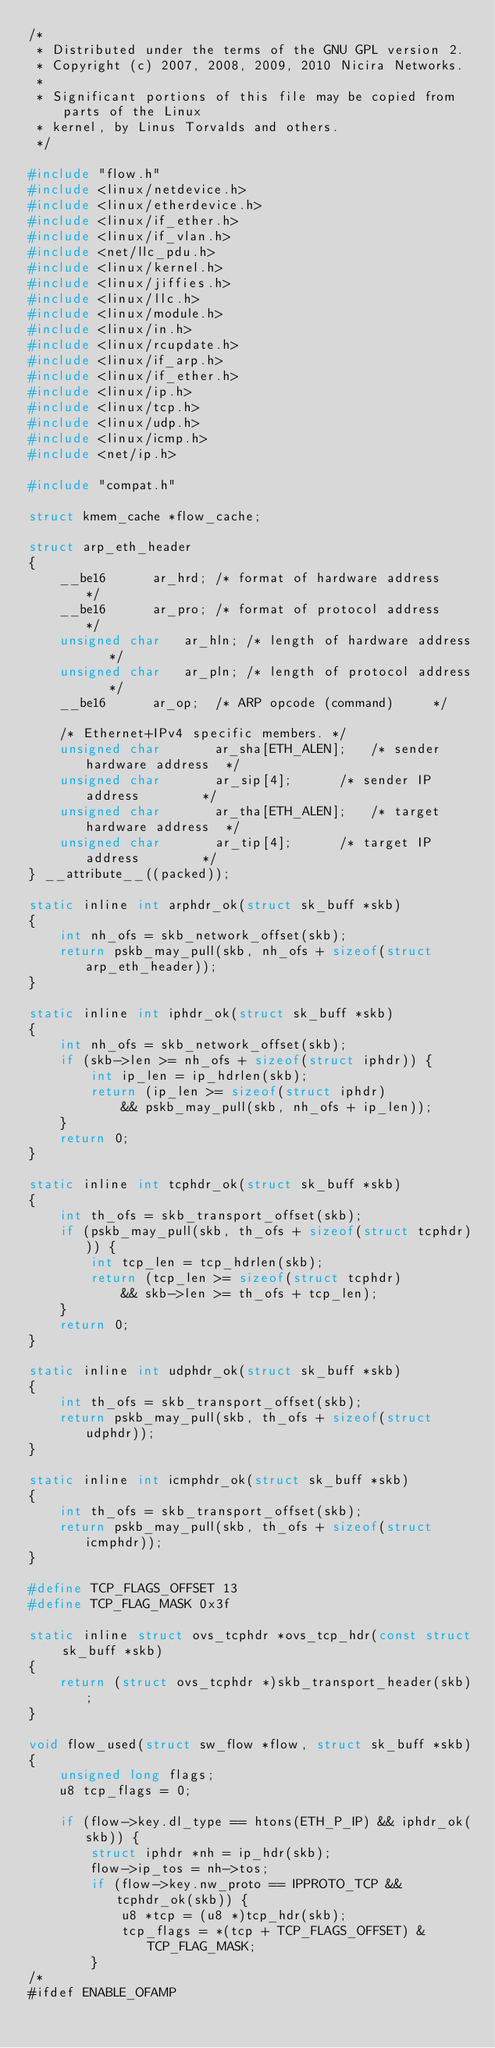Convert code to text. <code><loc_0><loc_0><loc_500><loc_500><_C_>/*
 * Distributed under the terms of the GNU GPL version 2.
 * Copyright (c) 2007, 2008, 2009, 2010 Nicira Networks.
 *
 * Significant portions of this file may be copied from parts of the Linux
 * kernel, by Linus Torvalds and others.
 */

#include "flow.h"
#include <linux/netdevice.h>
#include <linux/etherdevice.h>
#include <linux/if_ether.h>
#include <linux/if_vlan.h>
#include <net/llc_pdu.h>
#include <linux/kernel.h>
#include <linux/jiffies.h>
#include <linux/llc.h>
#include <linux/module.h>
#include <linux/in.h>
#include <linux/rcupdate.h>
#include <linux/if_arp.h>
#include <linux/if_ether.h>
#include <linux/ip.h>
#include <linux/tcp.h>
#include <linux/udp.h>
#include <linux/icmp.h>
#include <net/ip.h>

#include "compat.h"

struct kmem_cache *flow_cache;

struct arp_eth_header
{
	__be16      ar_hrd;	/* format of hardware address   */
	__be16      ar_pro;	/* format of protocol address   */
	unsigned char   ar_hln;	/* length of hardware address   */
	unsigned char   ar_pln;	/* length of protocol address   */
	__be16      ar_op;	/* ARP opcode (command)     */

	/* Ethernet+IPv4 specific members. */
	unsigned char       ar_sha[ETH_ALEN];	/* sender hardware address  */
	unsigned char       ar_sip[4];		/* sender IP address        */
	unsigned char       ar_tha[ETH_ALEN];	/* target hardware address  */
	unsigned char       ar_tip[4];		/* target IP address        */
} __attribute__((packed));

static inline int arphdr_ok(struct sk_buff *skb)
{
	int nh_ofs = skb_network_offset(skb);
	return pskb_may_pull(skb, nh_ofs + sizeof(struct arp_eth_header));
}

static inline int iphdr_ok(struct sk_buff *skb)
{
	int nh_ofs = skb_network_offset(skb);
	if (skb->len >= nh_ofs + sizeof(struct iphdr)) {
		int ip_len = ip_hdrlen(skb);
		return (ip_len >= sizeof(struct iphdr)
			&& pskb_may_pull(skb, nh_ofs + ip_len));
	}
	return 0;
}

static inline int tcphdr_ok(struct sk_buff *skb)
{
	int th_ofs = skb_transport_offset(skb);
	if (pskb_may_pull(skb, th_ofs + sizeof(struct tcphdr))) {
		int tcp_len = tcp_hdrlen(skb);
		return (tcp_len >= sizeof(struct tcphdr)
			&& skb->len >= th_ofs + tcp_len);
	}
	return 0;
}

static inline int udphdr_ok(struct sk_buff *skb)
{
	int th_ofs = skb_transport_offset(skb);
	return pskb_may_pull(skb, th_ofs + sizeof(struct udphdr));
}

static inline int icmphdr_ok(struct sk_buff *skb)
{
	int th_ofs = skb_transport_offset(skb);
	return pskb_may_pull(skb, th_ofs + sizeof(struct icmphdr));
}

#define TCP_FLAGS_OFFSET 13
#define TCP_FLAG_MASK 0x3f

static inline struct ovs_tcphdr *ovs_tcp_hdr(const struct sk_buff *skb)
{
	return (struct ovs_tcphdr *)skb_transport_header(skb);
}

void flow_used(struct sw_flow *flow, struct sk_buff *skb)
{
	unsigned long flags;
	u8 tcp_flags = 0;

	if (flow->key.dl_type == htons(ETH_P_IP) && iphdr_ok(skb)) {
		struct iphdr *nh = ip_hdr(skb);
		flow->ip_tos = nh->tos;
		if (flow->key.nw_proto == IPPROTO_TCP && tcphdr_ok(skb)) {
			u8 *tcp = (u8 *)tcp_hdr(skb);
			tcp_flags = *(tcp + TCP_FLAGS_OFFSET) & TCP_FLAG_MASK;
		}
/*
#ifdef ENABLE_OFAMP</code> 